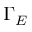<formula> <loc_0><loc_0><loc_500><loc_500>\Gamma _ { E }</formula> 